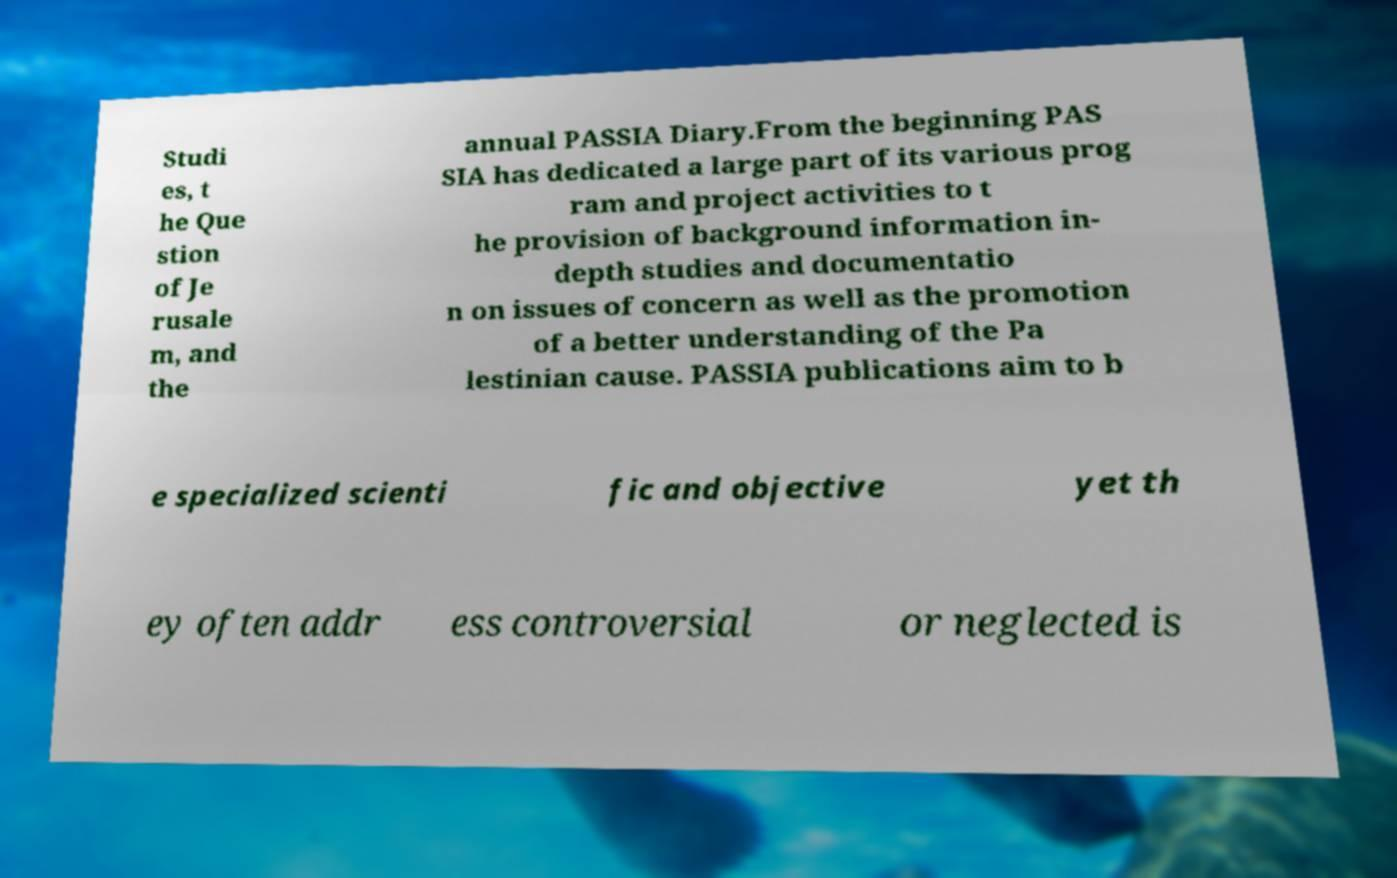Could you assist in decoding the text presented in this image and type it out clearly? Studi es, t he Que stion of Je rusale m, and the annual PASSIA Diary.From the beginning PAS SIA has dedicated a large part of its various prog ram and project activities to t he provision of background information in- depth studies and documentatio n on issues of concern as well as the promotion of a better understanding of the Pa lestinian cause. PASSIA publications aim to b e specialized scienti fic and objective yet th ey often addr ess controversial or neglected is 